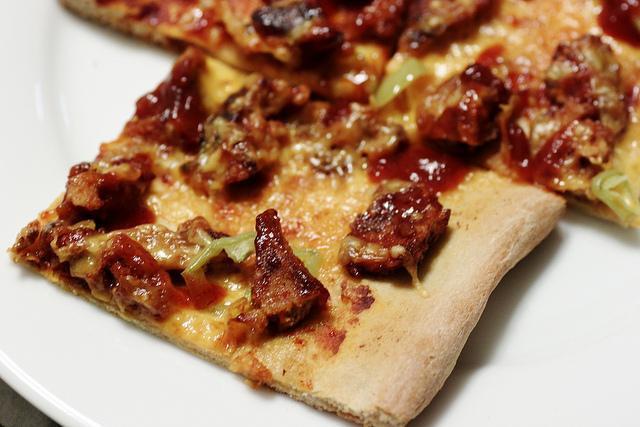How many pizzas can be seen?
Give a very brief answer. 1. 